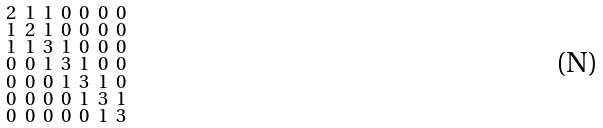Convert formula to latex. <formula><loc_0><loc_0><loc_500><loc_500>\begin{smallmatrix} 2 & 1 & 1 & 0 & 0 & 0 & 0 \\ 1 & 2 & 1 & 0 & 0 & 0 & 0 \\ 1 & 1 & 3 & 1 & 0 & 0 & 0 \\ 0 & 0 & 1 & 3 & 1 & 0 & 0 \\ 0 & 0 & 0 & 1 & 3 & 1 & 0 \\ 0 & 0 & 0 & 0 & 1 & 3 & 1 \\ 0 & 0 & 0 & 0 & 0 & 1 & 3 \end{smallmatrix}</formula> 